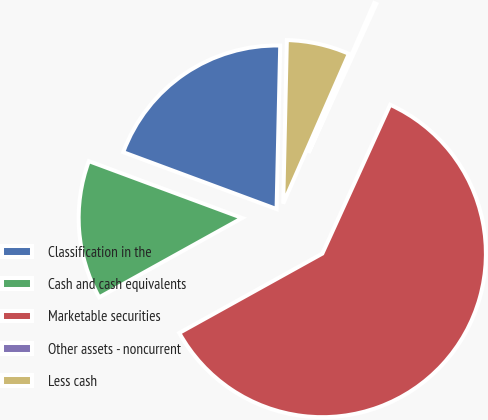Convert chart. <chart><loc_0><loc_0><loc_500><loc_500><pie_chart><fcel>Classification in the<fcel>Cash and cash equivalents<fcel>Marketable securities<fcel>Other assets - noncurrent<fcel>Less cash<nl><fcel>19.7%<fcel>13.71%<fcel>60.13%<fcel>0.23%<fcel>6.22%<nl></chart> 